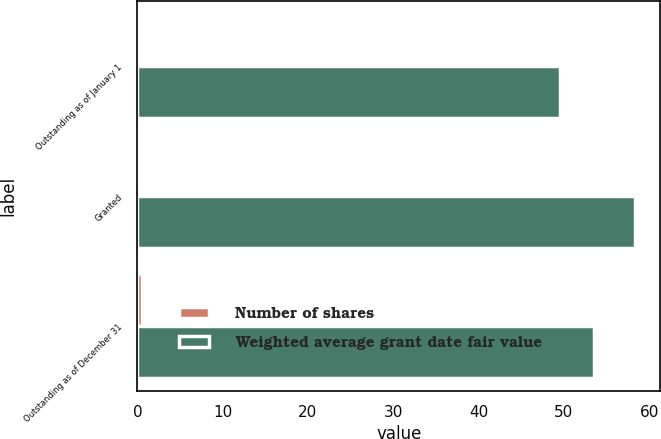<chart> <loc_0><loc_0><loc_500><loc_500><stacked_bar_chart><ecel><fcel>Outstanding as of January 1<fcel>Granted<fcel>Outstanding as of December 31<nl><fcel>Number of shares<fcel>0.3<fcel>0.2<fcel>0.5<nl><fcel>Weighted average grant date fair value<fcel>49.54<fcel>58.4<fcel>53.56<nl></chart> 